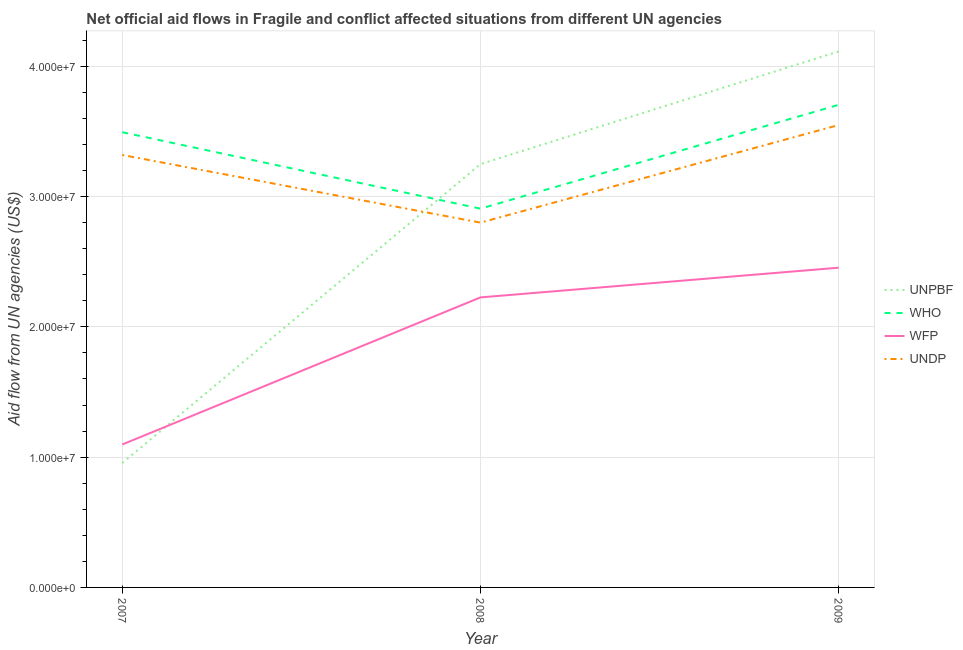What is the amount of aid given by unpbf in 2008?
Your answer should be compact. 3.25e+07. Across all years, what is the maximum amount of aid given by undp?
Offer a terse response. 3.55e+07. Across all years, what is the minimum amount of aid given by unpbf?
Keep it short and to the point. 9.55e+06. In which year was the amount of aid given by wfp maximum?
Your answer should be compact. 2009. What is the total amount of aid given by undp in the graph?
Make the answer very short. 9.67e+07. What is the difference between the amount of aid given by undp in 2008 and that in 2009?
Give a very brief answer. -7.49e+06. What is the difference between the amount of aid given by who in 2009 and the amount of aid given by unpbf in 2008?
Offer a very short reply. 4.55e+06. What is the average amount of aid given by who per year?
Give a very brief answer. 3.37e+07. In the year 2007, what is the difference between the amount of aid given by unpbf and amount of aid given by who?
Provide a succinct answer. -2.54e+07. What is the ratio of the amount of aid given by unpbf in 2007 to that in 2009?
Ensure brevity in your answer.  0.23. What is the difference between the highest and the second highest amount of aid given by unpbf?
Your answer should be very brief. 8.65e+06. What is the difference between the highest and the lowest amount of aid given by undp?
Provide a short and direct response. 7.49e+06. In how many years, is the amount of aid given by unpbf greater than the average amount of aid given by unpbf taken over all years?
Give a very brief answer. 2. Does the amount of aid given by wfp monotonically increase over the years?
Your response must be concise. Yes. Is the amount of aid given by undp strictly less than the amount of aid given by who over the years?
Your answer should be very brief. Yes. What is the difference between two consecutive major ticks on the Y-axis?
Provide a succinct answer. 1.00e+07. Does the graph contain any zero values?
Your response must be concise. No. What is the title of the graph?
Make the answer very short. Net official aid flows in Fragile and conflict affected situations from different UN agencies. Does "Custom duties" appear as one of the legend labels in the graph?
Offer a very short reply. No. What is the label or title of the X-axis?
Make the answer very short. Year. What is the label or title of the Y-axis?
Your response must be concise. Aid flow from UN agencies (US$). What is the Aid flow from UN agencies (US$) in UNPBF in 2007?
Your answer should be very brief. 9.55e+06. What is the Aid flow from UN agencies (US$) of WHO in 2007?
Your answer should be compact. 3.49e+07. What is the Aid flow from UN agencies (US$) in WFP in 2007?
Provide a short and direct response. 1.10e+07. What is the Aid flow from UN agencies (US$) of UNDP in 2007?
Provide a short and direct response. 3.32e+07. What is the Aid flow from UN agencies (US$) in UNPBF in 2008?
Keep it short and to the point. 3.25e+07. What is the Aid flow from UN agencies (US$) of WHO in 2008?
Make the answer very short. 2.91e+07. What is the Aid flow from UN agencies (US$) in WFP in 2008?
Keep it short and to the point. 2.23e+07. What is the Aid flow from UN agencies (US$) in UNDP in 2008?
Give a very brief answer. 2.80e+07. What is the Aid flow from UN agencies (US$) of UNPBF in 2009?
Offer a terse response. 4.11e+07. What is the Aid flow from UN agencies (US$) in WHO in 2009?
Your answer should be compact. 3.70e+07. What is the Aid flow from UN agencies (US$) in WFP in 2009?
Give a very brief answer. 2.45e+07. What is the Aid flow from UN agencies (US$) in UNDP in 2009?
Provide a succinct answer. 3.55e+07. Across all years, what is the maximum Aid flow from UN agencies (US$) of UNPBF?
Offer a terse response. 4.11e+07. Across all years, what is the maximum Aid flow from UN agencies (US$) in WHO?
Ensure brevity in your answer.  3.70e+07. Across all years, what is the maximum Aid flow from UN agencies (US$) in WFP?
Provide a short and direct response. 2.45e+07. Across all years, what is the maximum Aid flow from UN agencies (US$) in UNDP?
Your answer should be compact. 3.55e+07. Across all years, what is the minimum Aid flow from UN agencies (US$) in UNPBF?
Provide a succinct answer. 9.55e+06. Across all years, what is the minimum Aid flow from UN agencies (US$) of WHO?
Offer a very short reply. 2.91e+07. Across all years, what is the minimum Aid flow from UN agencies (US$) of WFP?
Make the answer very short. 1.10e+07. Across all years, what is the minimum Aid flow from UN agencies (US$) in UNDP?
Keep it short and to the point. 2.80e+07. What is the total Aid flow from UN agencies (US$) of UNPBF in the graph?
Offer a very short reply. 8.32e+07. What is the total Aid flow from UN agencies (US$) in WHO in the graph?
Give a very brief answer. 1.01e+08. What is the total Aid flow from UN agencies (US$) of WFP in the graph?
Keep it short and to the point. 5.78e+07. What is the total Aid flow from UN agencies (US$) in UNDP in the graph?
Provide a short and direct response. 9.67e+07. What is the difference between the Aid flow from UN agencies (US$) of UNPBF in 2007 and that in 2008?
Give a very brief answer. -2.29e+07. What is the difference between the Aid flow from UN agencies (US$) of WHO in 2007 and that in 2008?
Offer a very short reply. 5.87e+06. What is the difference between the Aid flow from UN agencies (US$) in WFP in 2007 and that in 2008?
Provide a succinct answer. -1.13e+07. What is the difference between the Aid flow from UN agencies (US$) in UNDP in 2007 and that in 2008?
Your answer should be very brief. 5.19e+06. What is the difference between the Aid flow from UN agencies (US$) of UNPBF in 2007 and that in 2009?
Your answer should be very brief. -3.16e+07. What is the difference between the Aid flow from UN agencies (US$) in WHO in 2007 and that in 2009?
Your response must be concise. -2.10e+06. What is the difference between the Aid flow from UN agencies (US$) in WFP in 2007 and that in 2009?
Provide a short and direct response. -1.36e+07. What is the difference between the Aid flow from UN agencies (US$) of UNDP in 2007 and that in 2009?
Provide a short and direct response. -2.30e+06. What is the difference between the Aid flow from UN agencies (US$) of UNPBF in 2008 and that in 2009?
Provide a short and direct response. -8.65e+06. What is the difference between the Aid flow from UN agencies (US$) in WHO in 2008 and that in 2009?
Give a very brief answer. -7.97e+06. What is the difference between the Aid flow from UN agencies (US$) of WFP in 2008 and that in 2009?
Offer a terse response. -2.28e+06. What is the difference between the Aid flow from UN agencies (US$) of UNDP in 2008 and that in 2009?
Offer a terse response. -7.49e+06. What is the difference between the Aid flow from UN agencies (US$) of UNPBF in 2007 and the Aid flow from UN agencies (US$) of WHO in 2008?
Provide a succinct answer. -1.95e+07. What is the difference between the Aid flow from UN agencies (US$) of UNPBF in 2007 and the Aid flow from UN agencies (US$) of WFP in 2008?
Offer a very short reply. -1.27e+07. What is the difference between the Aid flow from UN agencies (US$) in UNPBF in 2007 and the Aid flow from UN agencies (US$) in UNDP in 2008?
Provide a succinct answer. -1.84e+07. What is the difference between the Aid flow from UN agencies (US$) in WHO in 2007 and the Aid flow from UN agencies (US$) in WFP in 2008?
Make the answer very short. 1.27e+07. What is the difference between the Aid flow from UN agencies (US$) in WHO in 2007 and the Aid flow from UN agencies (US$) in UNDP in 2008?
Keep it short and to the point. 6.94e+06. What is the difference between the Aid flow from UN agencies (US$) of WFP in 2007 and the Aid flow from UN agencies (US$) of UNDP in 2008?
Keep it short and to the point. -1.70e+07. What is the difference between the Aid flow from UN agencies (US$) of UNPBF in 2007 and the Aid flow from UN agencies (US$) of WHO in 2009?
Provide a short and direct response. -2.75e+07. What is the difference between the Aid flow from UN agencies (US$) in UNPBF in 2007 and the Aid flow from UN agencies (US$) in WFP in 2009?
Your response must be concise. -1.50e+07. What is the difference between the Aid flow from UN agencies (US$) in UNPBF in 2007 and the Aid flow from UN agencies (US$) in UNDP in 2009?
Ensure brevity in your answer.  -2.59e+07. What is the difference between the Aid flow from UN agencies (US$) of WHO in 2007 and the Aid flow from UN agencies (US$) of WFP in 2009?
Give a very brief answer. 1.04e+07. What is the difference between the Aid flow from UN agencies (US$) in WHO in 2007 and the Aid flow from UN agencies (US$) in UNDP in 2009?
Ensure brevity in your answer.  -5.50e+05. What is the difference between the Aid flow from UN agencies (US$) of WFP in 2007 and the Aid flow from UN agencies (US$) of UNDP in 2009?
Provide a short and direct response. -2.45e+07. What is the difference between the Aid flow from UN agencies (US$) in UNPBF in 2008 and the Aid flow from UN agencies (US$) in WHO in 2009?
Your response must be concise. -4.55e+06. What is the difference between the Aid flow from UN agencies (US$) in UNPBF in 2008 and the Aid flow from UN agencies (US$) in WFP in 2009?
Offer a very short reply. 7.95e+06. What is the difference between the Aid flow from UN agencies (US$) of UNPBF in 2008 and the Aid flow from UN agencies (US$) of UNDP in 2009?
Give a very brief answer. -3.00e+06. What is the difference between the Aid flow from UN agencies (US$) in WHO in 2008 and the Aid flow from UN agencies (US$) in WFP in 2009?
Give a very brief answer. 4.53e+06. What is the difference between the Aid flow from UN agencies (US$) of WHO in 2008 and the Aid flow from UN agencies (US$) of UNDP in 2009?
Make the answer very short. -6.42e+06. What is the difference between the Aid flow from UN agencies (US$) in WFP in 2008 and the Aid flow from UN agencies (US$) in UNDP in 2009?
Keep it short and to the point. -1.32e+07. What is the average Aid flow from UN agencies (US$) in UNPBF per year?
Make the answer very short. 2.77e+07. What is the average Aid flow from UN agencies (US$) of WHO per year?
Provide a succinct answer. 3.37e+07. What is the average Aid flow from UN agencies (US$) of WFP per year?
Your answer should be compact. 1.93e+07. What is the average Aid flow from UN agencies (US$) of UNDP per year?
Keep it short and to the point. 3.22e+07. In the year 2007, what is the difference between the Aid flow from UN agencies (US$) in UNPBF and Aid flow from UN agencies (US$) in WHO?
Your answer should be very brief. -2.54e+07. In the year 2007, what is the difference between the Aid flow from UN agencies (US$) of UNPBF and Aid flow from UN agencies (US$) of WFP?
Your response must be concise. -1.42e+06. In the year 2007, what is the difference between the Aid flow from UN agencies (US$) of UNPBF and Aid flow from UN agencies (US$) of UNDP?
Provide a succinct answer. -2.36e+07. In the year 2007, what is the difference between the Aid flow from UN agencies (US$) in WHO and Aid flow from UN agencies (US$) in WFP?
Provide a succinct answer. 2.40e+07. In the year 2007, what is the difference between the Aid flow from UN agencies (US$) in WHO and Aid flow from UN agencies (US$) in UNDP?
Ensure brevity in your answer.  1.75e+06. In the year 2007, what is the difference between the Aid flow from UN agencies (US$) in WFP and Aid flow from UN agencies (US$) in UNDP?
Your response must be concise. -2.22e+07. In the year 2008, what is the difference between the Aid flow from UN agencies (US$) in UNPBF and Aid flow from UN agencies (US$) in WHO?
Provide a short and direct response. 3.42e+06. In the year 2008, what is the difference between the Aid flow from UN agencies (US$) of UNPBF and Aid flow from UN agencies (US$) of WFP?
Your answer should be compact. 1.02e+07. In the year 2008, what is the difference between the Aid flow from UN agencies (US$) of UNPBF and Aid flow from UN agencies (US$) of UNDP?
Offer a very short reply. 4.49e+06. In the year 2008, what is the difference between the Aid flow from UN agencies (US$) of WHO and Aid flow from UN agencies (US$) of WFP?
Give a very brief answer. 6.81e+06. In the year 2008, what is the difference between the Aid flow from UN agencies (US$) of WHO and Aid flow from UN agencies (US$) of UNDP?
Give a very brief answer. 1.07e+06. In the year 2008, what is the difference between the Aid flow from UN agencies (US$) in WFP and Aid flow from UN agencies (US$) in UNDP?
Provide a succinct answer. -5.74e+06. In the year 2009, what is the difference between the Aid flow from UN agencies (US$) in UNPBF and Aid flow from UN agencies (US$) in WHO?
Your answer should be compact. 4.10e+06. In the year 2009, what is the difference between the Aid flow from UN agencies (US$) in UNPBF and Aid flow from UN agencies (US$) in WFP?
Offer a terse response. 1.66e+07. In the year 2009, what is the difference between the Aid flow from UN agencies (US$) of UNPBF and Aid flow from UN agencies (US$) of UNDP?
Provide a short and direct response. 5.65e+06. In the year 2009, what is the difference between the Aid flow from UN agencies (US$) in WHO and Aid flow from UN agencies (US$) in WFP?
Keep it short and to the point. 1.25e+07. In the year 2009, what is the difference between the Aid flow from UN agencies (US$) in WHO and Aid flow from UN agencies (US$) in UNDP?
Ensure brevity in your answer.  1.55e+06. In the year 2009, what is the difference between the Aid flow from UN agencies (US$) in WFP and Aid flow from UN agencies (US$) in UNDP?
Ensure brevity in your answer.  -1.10e+07. What is the ratio of the Aid flow from UN agencies (US$) in UNPBF in 2007 to that in 2008?
Offer a terse response. 0.29. What is the ratio of the Aid flow from UN agencies (US$) in WHO in 2007 to that in 2008?
Keep it short and to the point. 1.2. What is the ratio of the Aid flow from UN agencies (US$) in WFP in 2007 to that in 2008?
Your answer should be compact. 0.49. What is the ratio of the Aid flow from UN agencies (US$) in UNDP in 2007 to that in 2008?
Your answer should be compact. 1.19. What is the ratio of the Aid flow from UN agencies (US$) of UNPBF in 2007 to that in 2009?
Your response must be concise. 0.23. What is the ratio of the Aid flow from UN agencies (US$) in WHO in 2007 to that in 2009?
Offer a terse response. 0.94. What is the ratio of the Aid flow from UN agencies (US$) of WFP in 2007 to that in 2009?
Provide a short and direct response. 0.45. What is the ratio of the Aid flow from UN agencies (US$) of UNDP in 2007 to that in 2009?
Provide a succinct answer. 0.94. What is the ratio of the Aid flow from UN agencies (US$) in UNPBF in 2008 to that in 2009?
Your answer should be compact. 0.79. What is the ratio of the Aid flow from UN agencies (US$) of WHO in 2008 to that in 2009?
Your answer should be compact. 0.78. What is the ratio of the Aid flow from UN agencies (US$) of WFP in 2008 to that in 2009?
Offer a terse response. 0.91. What is the ratio of the Aid flow from UN agencies (US$) in UNDP in 2008 to that in 2009?
Your answer should be compact. 0.79. What is the difference between the highest and the second highest Aid flow from UN agencies (US$) of UNPBF?
Keep it short and to the point. 8.65e+06. What is the difference between the highest and the second highest Aid flow from UN agencies (US$) of WHO?
Offer a very short reply. 2.10e+06. What is the difference between the highest and the second highest Aid flow from UN agencies (US$) in WFP?
Your answer should be compact. 2.28e+06. What is the difference between the highest and the second highest Aid flow from UN agencies (US$) of UNDP?
Your answer should be very brief. 2.30e+06. What is the difference between the highest and the lowest Aid flow from UN agencies (US$) in UNPBF?
Your answer should be compact. 3.16e+07. What is the difference between the highest and the lowest Aid flow from UN agencies (US$) of WHO?
Make the answer very short. 7.97e+06. What is the difference between the highest and the lowest Aid flow from UN agencies (US$) in WFP?
Your answer should be compact. 1.36e+07. What is the difference between the highest and the lowest Aid flow from UN agencies (US$) of UNDP?
Your answer should be very brief. 7.49e+06. 